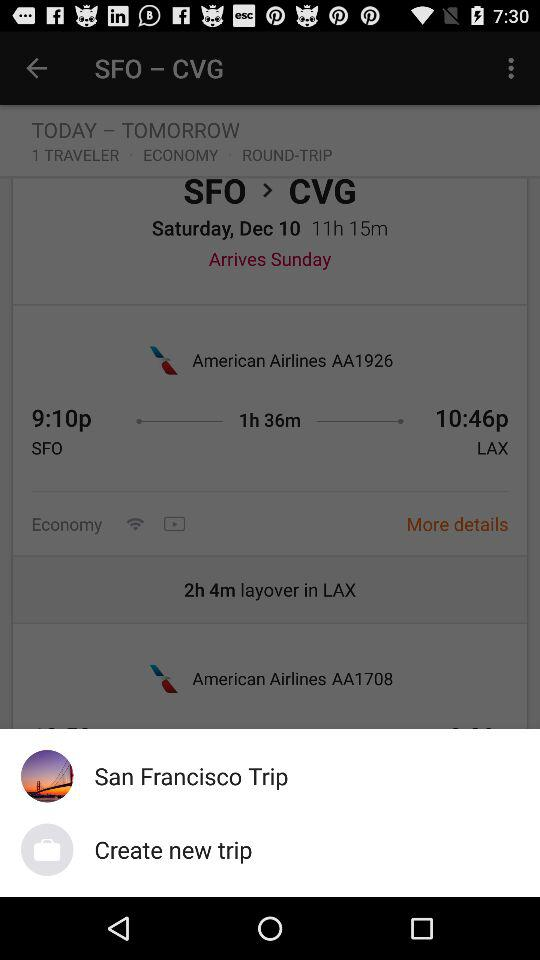What is the date? The date is Saturday, December 10. 